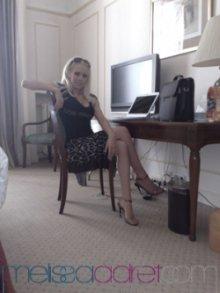Is she wearing a floor length skirt?
Concise answer only. No. What color is the girl's hair?
Give a very brief answer. Blonde. Is this a hotel?
Write a very short answer. Yes. What is the name of the furniture maker?
Quick response, please. Ikea. Where are the books?
Give a very brief answer. No books. 